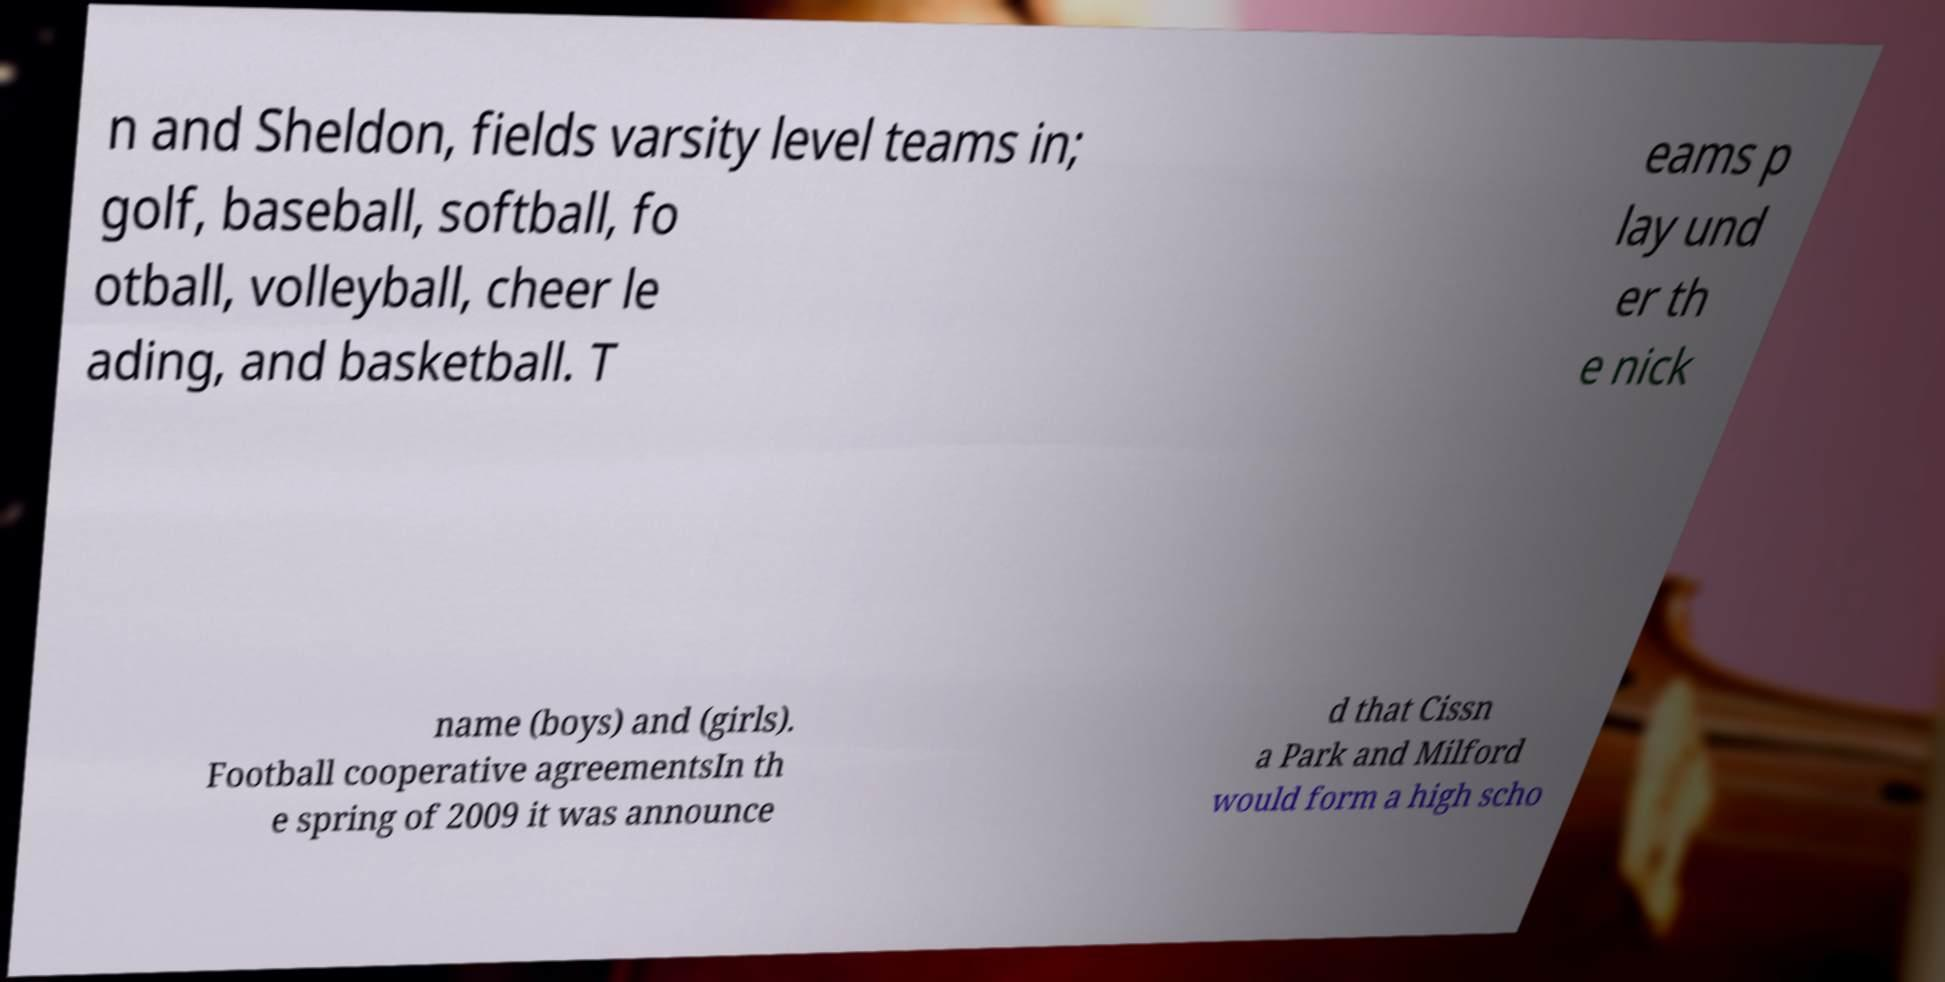Can you read and provide the text displayed in the image?This photo seems to have some interesting text. Can you extract and type it out for me? n and Sheldon, fields varsity level teams in; golf, baseball, softball, fo otball, volleyball, cheer le ading, and basketball. T eams p lay und er th e nick name (boys) and (girls). Football cooperative agreementsIn th e spring of 2009 it was announce d that Cissn a Park and Milford would form a high scho 